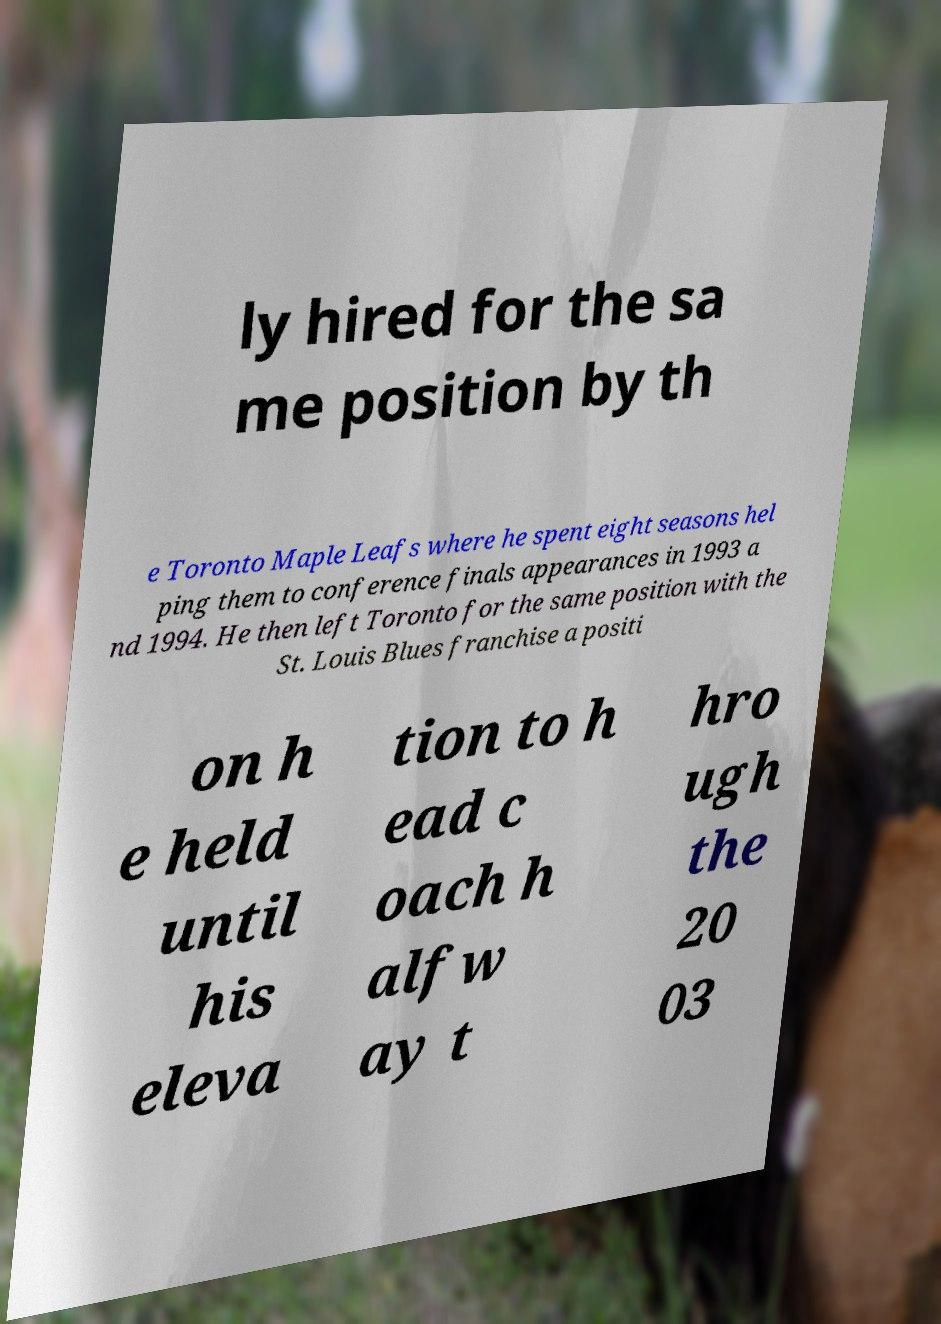Could you extract and type out the text from this image? ly hired for the sa me position by th e Toronto Maple Leafs where he spent eight seasons hel ping them to conference finals appearances in 1993 a nd 1994. He then left Toronto for the same position with the St. Louis Blues franchise a positi on h e held until his eleva tion to h ead c oach h alfw ay t hro ugh the 20 03 